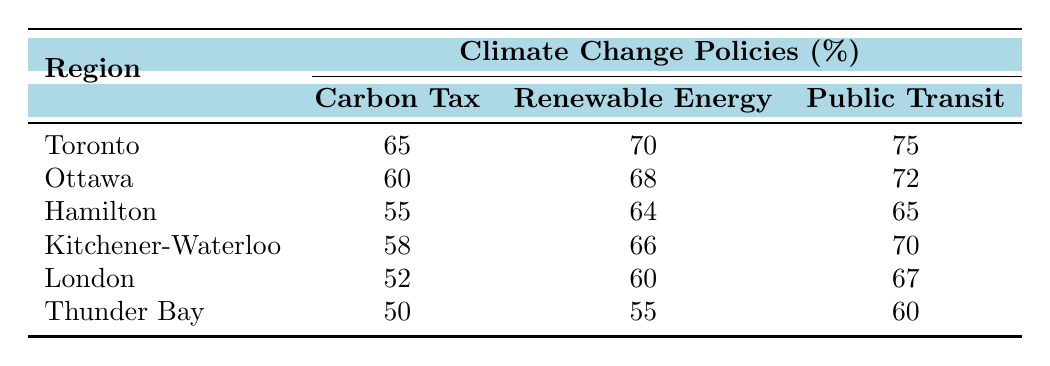What region has the highest support for renewable energy investment? The table shows that Toronto has the highest support at 70%.
Answer: Toronto What is the percentage of opposition to the carbon tax in Hamilton? According to the table, the percentage of opposition to the carbon tax in Hamilton is 40%.
Answer: 40% Which region has the lowest support for public transit expansion? The smallest support for public transit expansion is in Thunder Bay, where 60% support it.
Answer: Thunder Bay What is the average support for carbon tax across all regions? Adding the support values (65 + 60 + 55 + 58 + 52 + 50 = 340) and dividing by 6 gives an average of 56.67%.
Answer: 56.67% Is opposition to renewable energy investment greater in London than in Thunder Bay? In London, opposition is 32%, while in Thunder Bay, it is 35%. Thus the statement is false.
Answer: No What is the sum of support percentages for renewable energy investment in Toronto and Ottawa? The support percentages are 70% for Toronto and 68% for Ottawa. Their sum is 70 + 68 = 138%.
Answer: 138% Which region shows the greatest difference between support for carbon tax and support for renewable energy investment? Looking at the values, Toronto has a difference of 5% (70% - 65%), and Thunder Bay has a difference of 5% (55% - 50%). Therefore, both have the greatest difference, which is 5%.
Answer: 5% What percentage of people in Hamilton are neutral about carbon tax? In Hamilton, the neutral percentage regarding carbon tax is 5%, as indicated in the table.
Answer: 5% What comparison can be made about support for public transit expansion between Kitchener-Waterloo and London? Kitchener-Waterloo has a support of 70%, while London has 67%. Kitchener-Waterloo has a slightly higher support.
Answer: Kitchener-Waterloo has higher support Which region has the least opposition to renewable energy investment? The table indicates that Toronto has the least opposition to renewable energy investment at 20%.
Answer: Toronto 